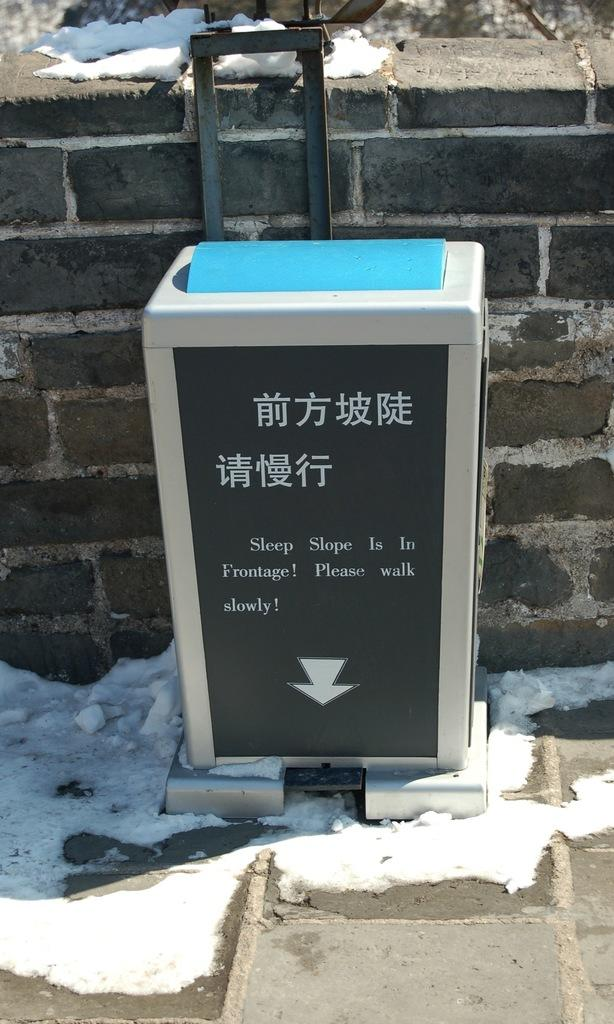<image>
Write a terse but informative summary of the picture. a box like sign telling you to watch your step on the slope sidewalk 